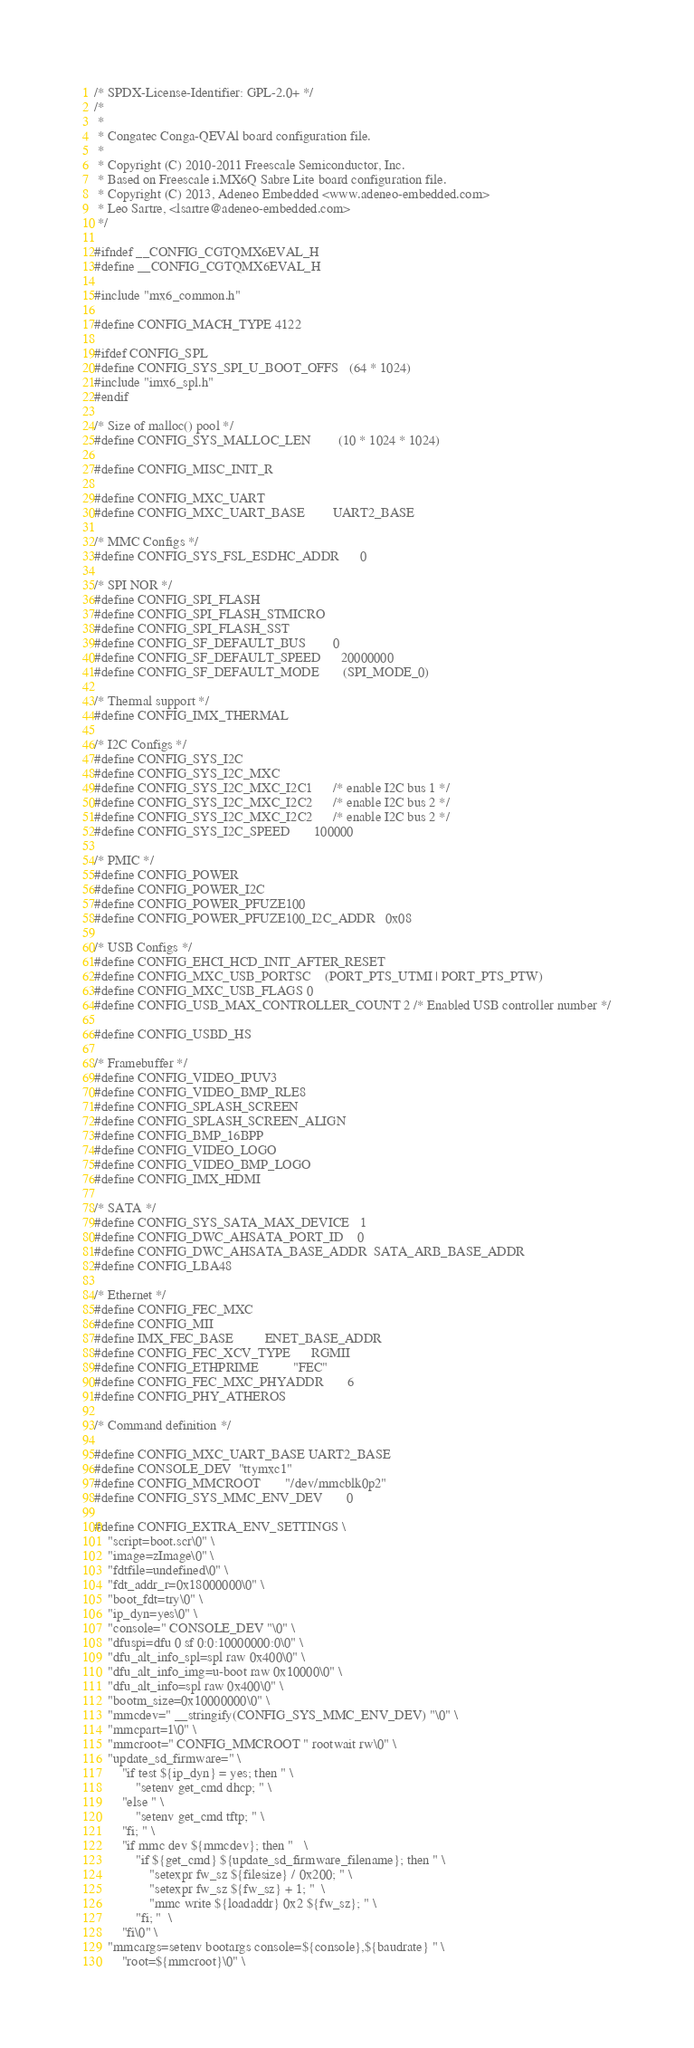<code> <loc_0><loc_0><loc_500><loc_500><_C_>/* SPDX-License-Identifier: GPL-2.0+ */
/*
 *
 * Congatec Conga-QEVAl board configuration file.
 *
 * Copyright (C) 2010-2011 Freescale Semiconductor, Inc.
 * Based on Freescale i.MX6Q Sabre Lite board configuration file.
 * Copyright (C) 2013, Adeneo Embedded <www.adeneo-embedded.com>
 * Leo Sartre, <lsartre@adeneo-embedded.com>
 */

#ifndef __CONFIG_CGTQMX6EVAL_H
#define __CONFIG_CGTQMX6EVAL_H

#include "mx6_common.h"

#define CONFIG_MACH_TYPE	4122

#ifdef CONFIG_SPL
#define CONFIG_SYS_SPI_U_BOOT_OFFS	(64 * 1024)
#include "imx6_spl.h"
#endif

/* Size of malloc() pool */
#define CONFIG_SYS_MALLOC_LEN		(10 * 1024 * 1024)

#define CONFIG_MISC_INIT_R

#define CONFIG_MXC_UART
#define CONFIG_MXC_UART_BASE	       UART2_BASE

/* MMC Configs */
#define CONFIG_SYS_FSL_ESDHC_ADDR      0

/* SPI NOR */
#define CONFIG_SPI_FLASH
#define CONFIG_SPI_FLASH_STMICRO
#define CONFIG_SPI_FLASH_SST
#define CONFIG_SF_DEFAULT_BUS		0
#define CONFIG_SF_DEFAULT_SPEED		20000000
#define CONFIG_SF_DEFAULT_MODE		(SPI_MODE_0)

/* Thermal support */
#define CONFIG_IMX_THERMAL

/* I2C Configs */
#define CONFIG_SYS_I2C
#define CONFIG_SYS_I2C_MXC
#define CONFIG_SYS_I2C_MXC_I2C1		/* enable I2C bus 1 */
#define CONFIG_SYS_I2C_MXC_I2C2		/* enable I2C bus 2 */
#define CONFIG_SYS_I2C_MXC_I2C2		/* enable I2C bus 2 */
#define CONFIG_SYS_I2C_SPEED		  100000

/* PMIC */
#define CONFIG_POWER
#define CONFIG_POWER_I2C
#define CONFIG_POWER_PFUZE100
#define CONFIG_POWER_PFUZE100_I2C_ADDR	0x08

/* USB Configs */
#define CONFIG_EHCI_HCD_INIT_AFTER_RESET
#define CONFIG_MXC_USB_PORTSC	(PORT_PTS_UTMI | PORT_PTS_PTW)
#define CONFIG_MXC_USB_FLAGS	0
#define CONFIG_USB_MAX_CONTROLLER_COUNT 2 /* Enabled USB controller number */

#define CONFIG_USBD_HS

/* Framebuffer */
#define CONFIG_VIDEO_IPUV3
#define CONFIG_VIDEO_BMP_RLE8
#define CONFIG_SPLASH_SCREEN
#define CONFIG_SPLASH_SCREEN_ALIGN
#define CONFIG_BMP_16BPP
#define CONFIG_VIDEO_LOGO
#define CONFIG_VIDEO_BMP_LOGO
#define CONFIG_IMX_HDMI

/* SATA */
#define CONFIG_SYS_SATA_MAX_DEVICE	1
#define CONFIG_DWC_AHSATA_PORT_ID	0
#define CONFIG_DWC_AHSATA_BASE_ADDR	SATA_ARB_BASE_ADDR
#define CONFIG_LBA48

/* Ethernet */
#define CONFIG_FEC_MXC
#define CONFIG_MII
#define IMX_FEC_BASE			ENET_BASE_ADDR
#define CONFIG_FEC_XCV_TYPE		RGMII
#define CONFIG_ETHPRIME			"FEC"
#define CONFIG_FEC_MXC_PHYADDR		6
#define CONFIG_PHY_ATHEROS

/* Command definition */

#define CONFIG_MXC_UART_BASE	UART2_BASE
#define CONSOLE_DEV	"ttymxc1"
#define CONFIG_MMCROOT		"/dev/mmcblk0p2"
#define CONFIG_SYS_MMC_ENV_DEV		0

#define CONFIG_EXTRA_ENV_SETTINGS \
	"script=boot.scr\0" \
	"image=zImage\0" \
	"fdtfile=undefined\0" \
	"fdt_addr_r=0x18000000\0" \
	"boot_fdt=try\0" \
	"ip_dyn=yes\0" \
	"console=" CONSOLE_DEV "\0" \
	"dfuspi=dfu 0 sf 0:0:10000000:0\0" \
	"dfu_alt_info_spl=spl raw 0x400\0" \
	"dfu_alt_info_img=u-boot raw 0x10000\0" \
	"dfu_alt_info=spl raw 0x400\0" \
	"bootm_size=0x10000000\0" \
	"mmcdev=" __stringify(CONFIG_SYS_MMC_ENV_DEV) "\0" \
	"mmcpart=1\0" \
	"mmcroot=" CONFIG_MMCROOT " rootwait rw\0" \
	"update_sd_firmware=" \
		"if test ${ip_dyn} = yes; then " \
			"setenv get_cmd dhcp; " \
		"else " \
			"setenv get_cmd tftp; " \
		"fi; " \
		"if mmc dev ${mmcdev}; then "	\
			"if ${get_cmd} ${update_sd_firmware_filename}; then " \
				"setexpr fw_sz ${filesize} / 0x200; " \
				"setexpr fw_sz ${fw_sz} + 1; "	\
				"mmc write ${loadaddr} 0x2 ${fw_sz}; " \
			"fi; "	\
		"fi\0" \
	"mmcargs=setenv bootargs console=${console},${baudrate} " \
		"root=${mmcroot}\0" \</code> 